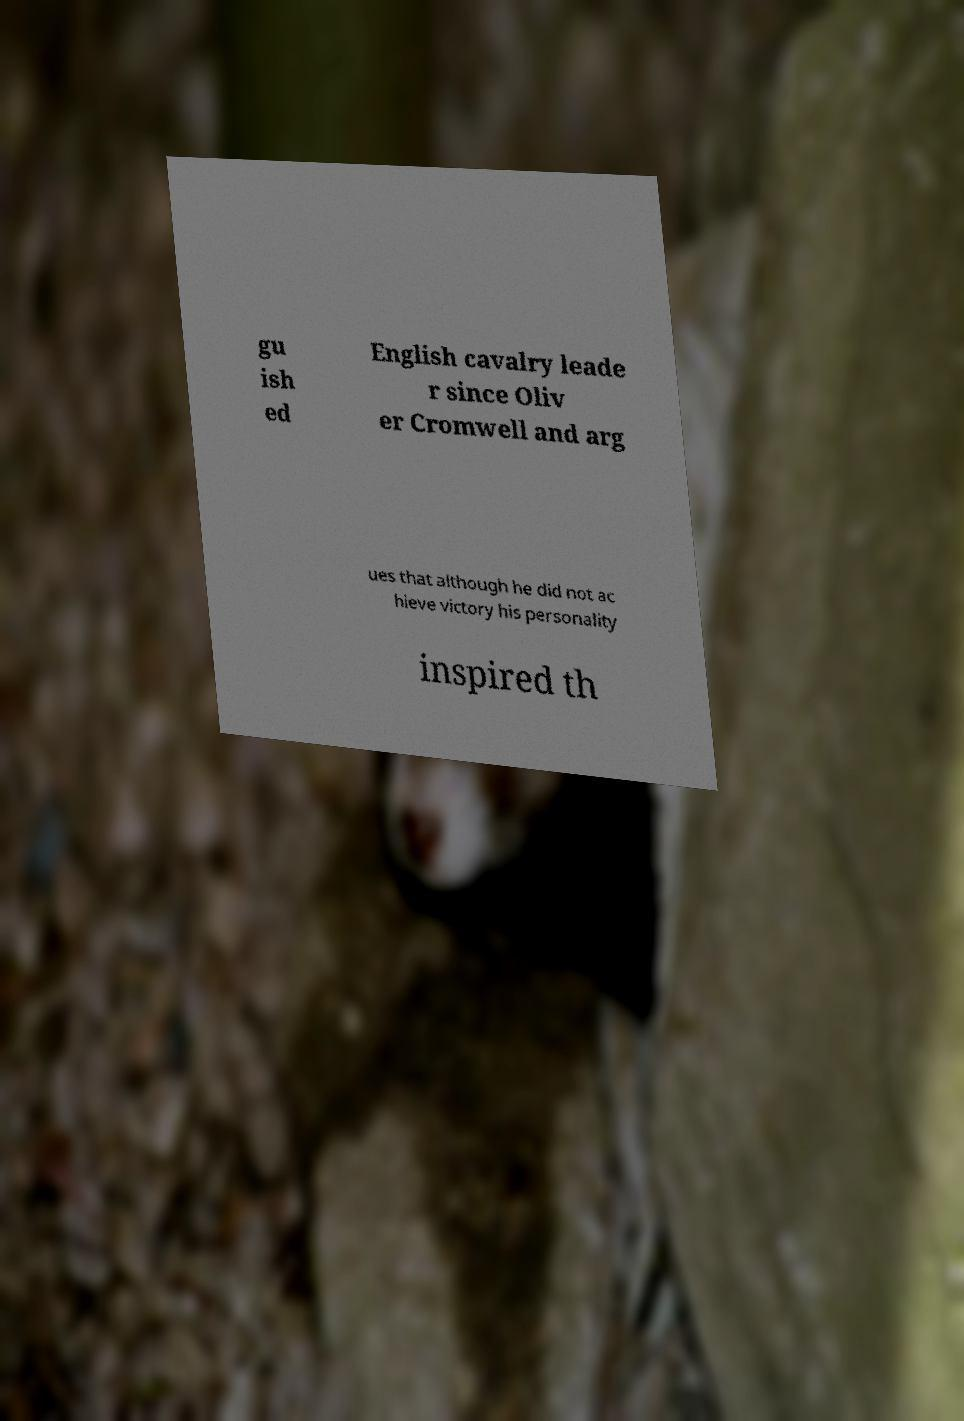What messages or text are displayed in this image? I need them in a readable, typed format. gu ish ed English cavalry leade r since Oliv er Cromwell and arg ues that although he did not ac hieve victory his personality inspired th 